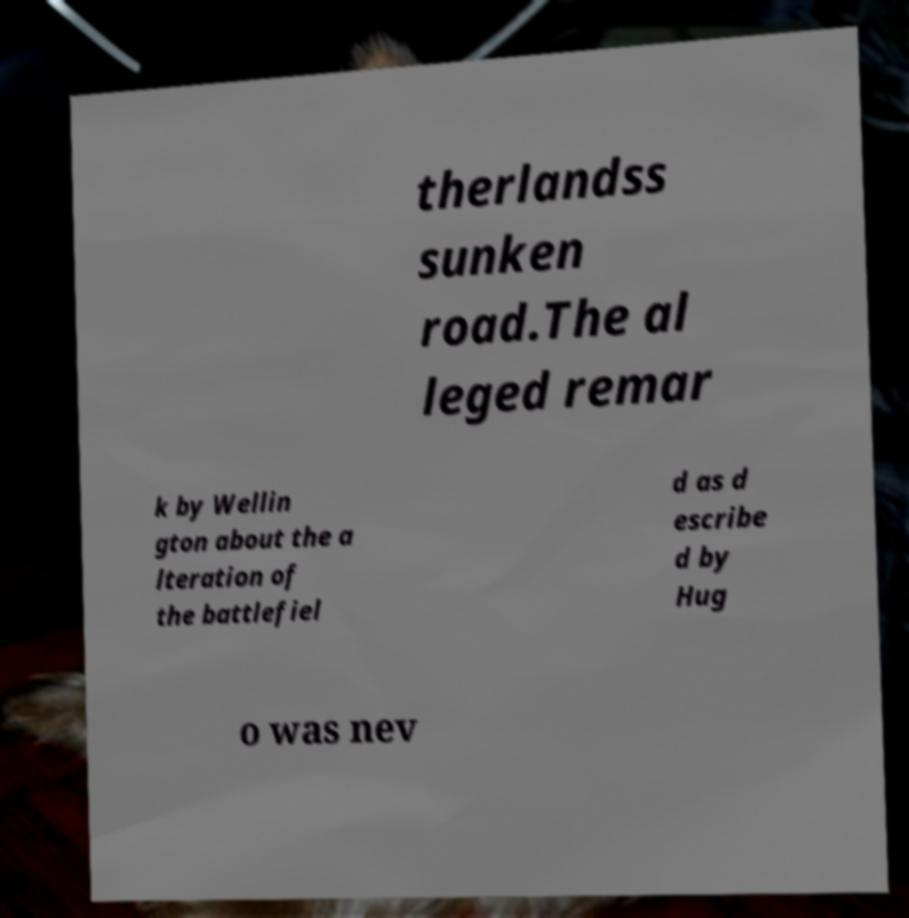For documentation purposes, I need the text within this image transcribed. Could you provide that? therlandss sunken road.The al leged remar k by Wellin gton about the a lteration of the battlefiel d as d escribe d by Hug o was nev 